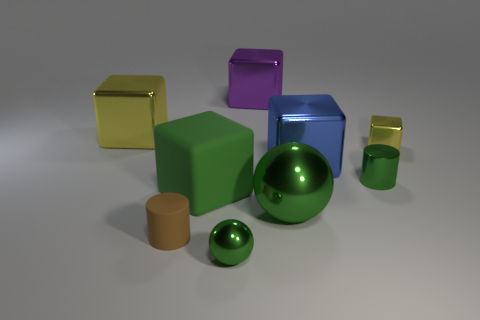Subtract all purple cubes. How many cubes are left? 4 Subtract all small metal blocks. How many blocks are left? 4 Subtract all gray blocks. Subtract all purple balls. How many blocks are left? 5 Subtract all cylinders. How many objects are left? 7 Subtract 0 cyan cylinders. How many objects are left? 9 Subtract all blue metal objects. Subtract all tiny green balls. How many objects are left? 7 Add 1 small balls. How many small balls are left? 2 Add 7 big yellow matte cubes. How many big yellow matte cubes exist? 7 